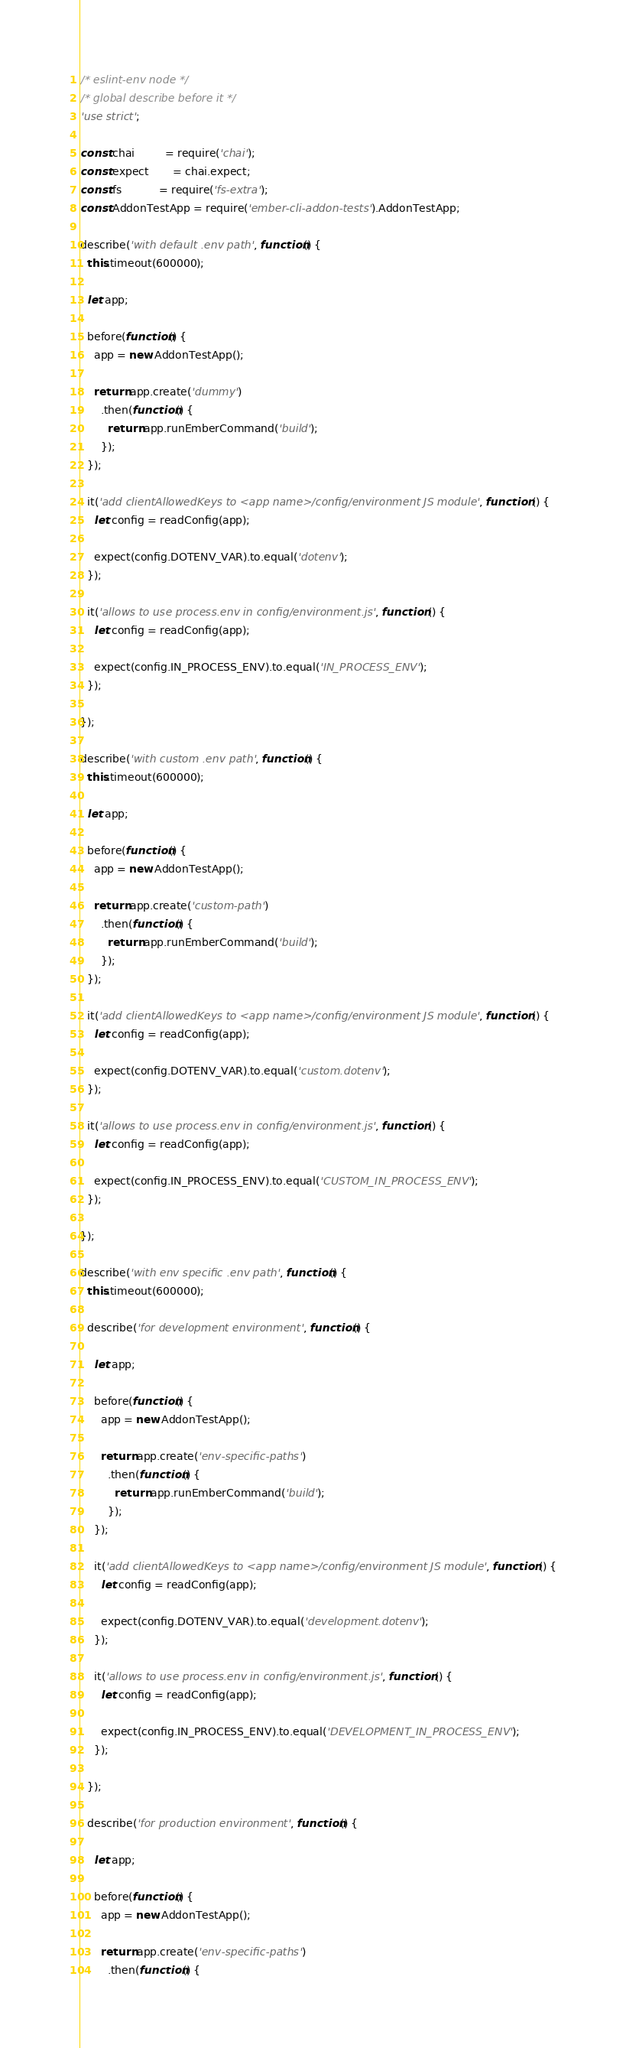<code> <loc_0><loc_0><loc_500><loc_500><_JavaScript_>/* eslint-env node */
/* global describe before it */
'use strict';

const chai         = require('chai');
const expect       = chai.expect;
const fs           = require('fs-extra');
const AddonTestApp = require('ember-cli-addon-tests').AddonTestApp;

describe('with default .env path', function() {
  this.timeout(600000);

  let app;

  before(function() {
    app = new AddonTestApp();

    return app.create('dummy')
      .then(function() {
        return app.runEmberCommand('build');
      });
  });

  it('add clientAllowedKeys to <app name>/config/environment JS module', function () {
    let config = readConfig(app);

    expect(config.DOTENV_VAR).to.equal('dotenv');
  });

  it('allows to use process.env in config/environment.js', function () {
    let config = readConfig(app);

    expect(config.IN_PROCESS_ENV).to.equal('IN_PROCESS_ENV');
  });

});

describe('with custom .env path', function() {
  this.timeout(600000);

  let app;

  before(function() {
    app = new AddonTestApp();

    return app.create('custom-path')
      .then(function() {
        return app.runEmberCommand('build');
      });
  });

  it('add clientAllowedKeys to <app name>/config/environment JS module', function () {
    let config = readConfig(app);

    expect(config.DOTENV_VAR).to.equal('custom.dotenv');
  });

  it('allows to use process.env in config/environment.js', function () {
    let config = readConfig(app);

    expect(config.IN_PROCESS_ENV).to.equal('CUSTOM_IN_PROCESS_ENV');
  });

});

describe('with env specific .env path', function() {
  this.timeout(600000);

  describe('for development environment', function() {

    let app;

    before(function() {
      app = new AddonTestApp();

      return app.create('env-specific-paths')
        .then(function() {
          return app.runEmberCommand('build');
        });
    });

    it('add clientAllowedKeys to <app name>/config/environment JS module', function () {
      let config = readConfig(app);

      expect(config.DOTENV_VAR).to.equal('development.dotenv');
    });

    it('allows to use process.env in config/environment.js', function () {
      let config = readConfig(app);

      expect(config.IN_PROCESS_ENV).to.equal('DEVELOPMENT_IN_PROCESS_ENV');
    });

  });

  describe('for production environment', function() {

    let app;

    before(function() {
      app = new AddonTestApp();

      return app.create('env-specific-paths')
        .then(function() {</code> 